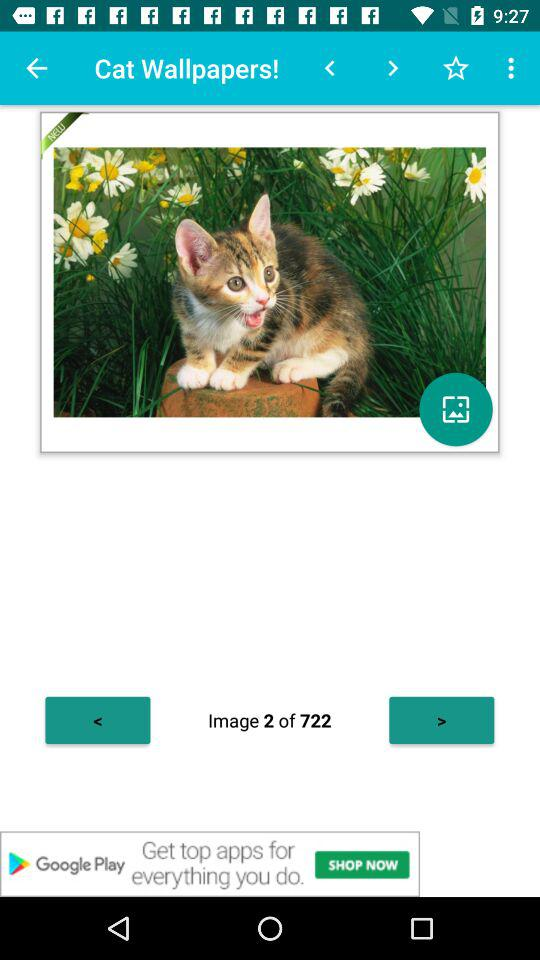What image is open now? The open image is of "Cat Wallpapers!". 